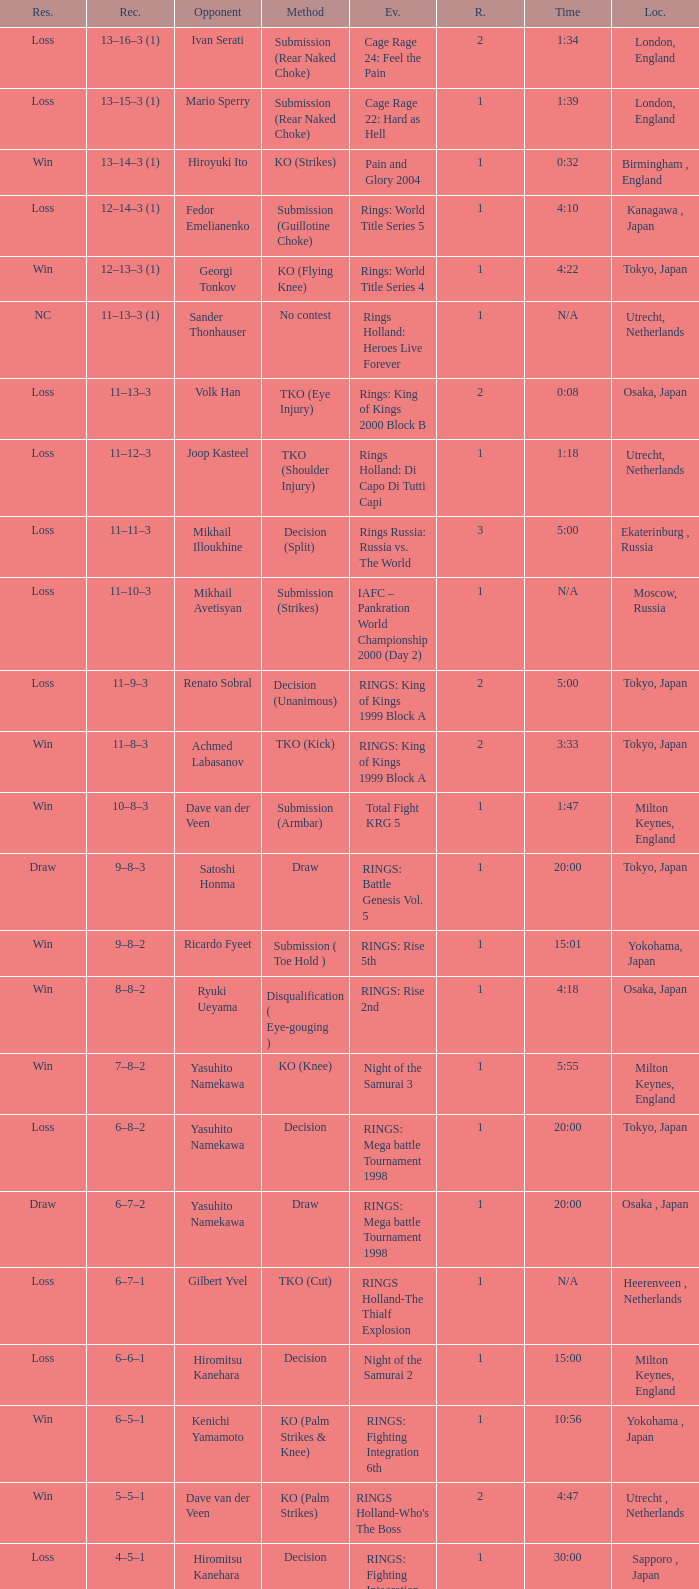Who was the opponent in London, England in a round less than 2? Mario Sperry. 